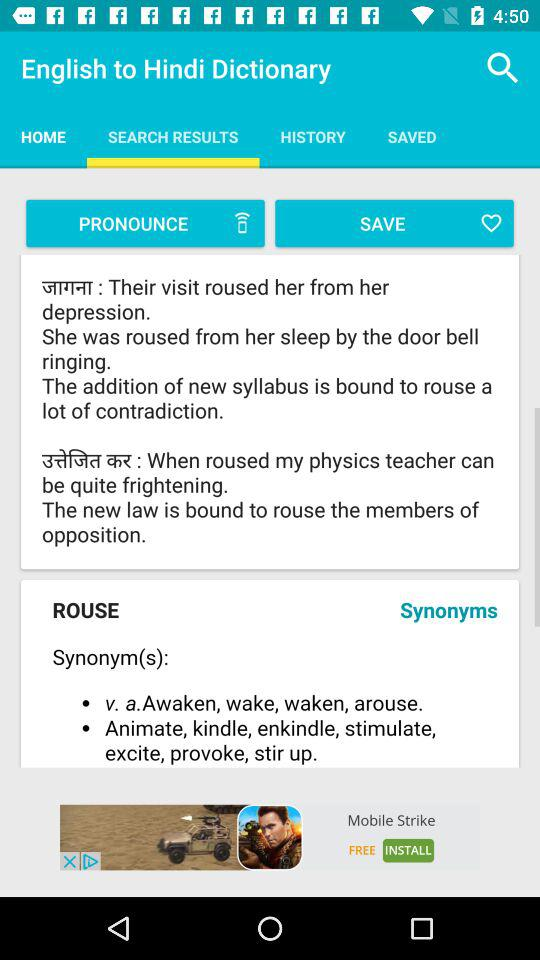Which tab is selected? The selected tab is "SEARCH RESULTS". 